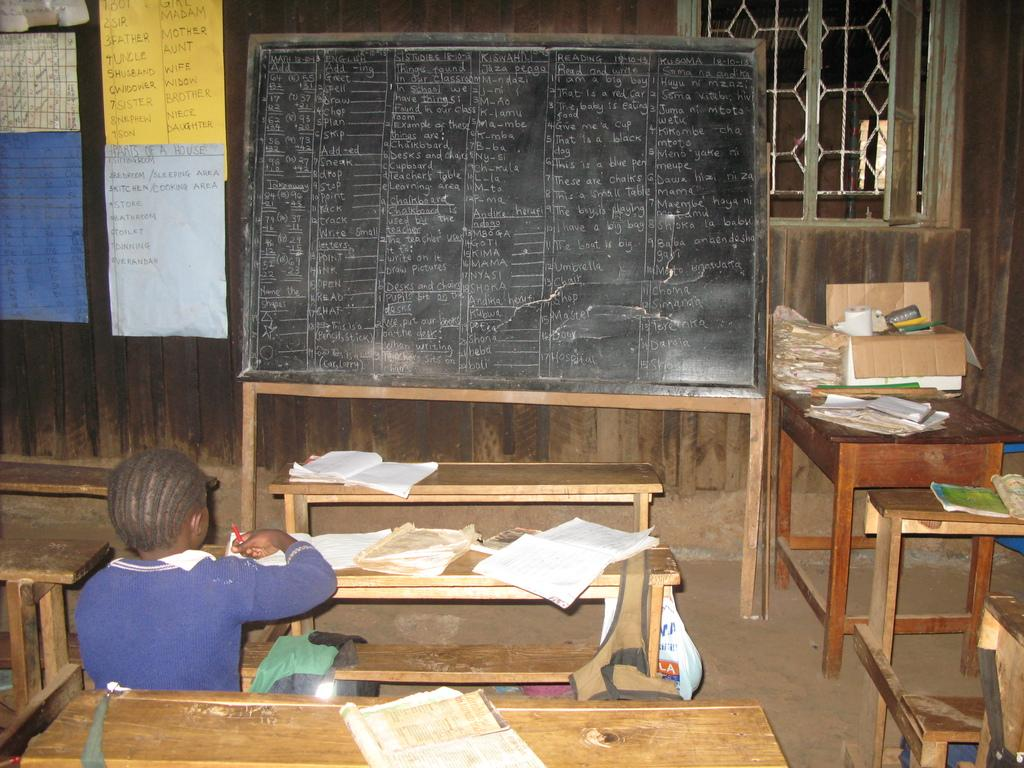What type of furniture is present in the image? There is a table and benches in the image. What items can be seen on the table? There are books and a box on the table. What is the person in the image doing? There is a person sitting on a bench. What can be seen in the background of the image? There are posters, a board, a wall, and a window in the background of the image. What type of card is being used to promote peace in the image? There is no card or promotion of peace present in the image. 